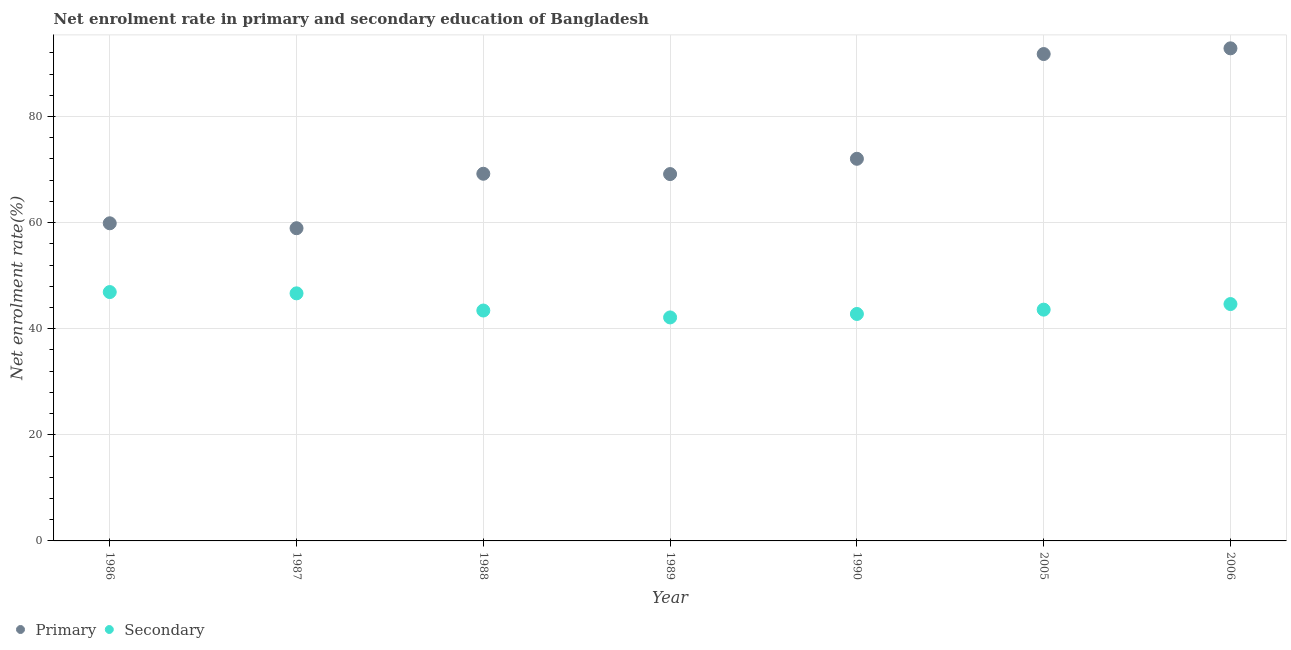Is the number of dotlines equal to the number of legend labels?
Offer a terse response. Yes. What is the enrollment rate in primary education in 1987?
Provide a short and direct response. 58.95. Across all years, what is the maximum enrollment rate in secondary education?
Keep it short and to the point. 46.91. Across all years, what is the minimum enrollment rate in primary education?
Provide a short and direct response. 58.95. In which year was the enrollment rate in secondary education maximum?
Provide a short and direct response. 1986. What is the total enrollment rate in primary education in the graph?
Give a very brief answer. 513.84. What is the difference between the enrollment rate in secondary education in 1987 and that in 2005?
Offer a terse response. 3.07. What is the difference between the enrollment rate in primary education in 1987 and the enrollment rate in secondary education in 1988?
Provide a short and direct response. 15.51. What is the average enrollment rate in primary education per year?
Make the answer very short. 73.41. In the year 1988, what is the difference between the enrollment rate in secondary education and enrollment rate in primary education?
Your answer should be very brief. -25.78. What is the ratio of the enrollment rate in secondary education in 1988 to that in 1990?
Ensure brevity in your answer.  1.02. What is the difference between the highest and the second highest enrollment rate in secondary education?
Offer a terse response. 0.24. What is the difference between the highest and the lowest enrollment rate in secondary education?
Offer a very short reply. 4.78. In how many years, is the enrollment rate in primary education greater than the average enrollment rate in primary education taken over all years?
Offer a very short reply. 2. Does the enrollment rate in primary education monotonically increase over the years?
Provide a short and direct response. No. Is the enrollment rate in secondary education strictly greater than the enrollment rate in primary education over the years?
Make the answer very short. No. How many dotlines are there?
Your response must be concise. 2. How many years are there in the graph?
Your response must be concise. 7. What is the difference between two consecutive major ticks on the Y-axis?
Provide a short and direct response. 20. Are the values on the major ticks of Y-axis written in scientific E-notation?
Ensure brevity in your answer.  No. How are the legend labels stacked?
Your answer should be very brief. Horizontal. What is the title of the graph?
Make the answer very short. Net enrolment rate in primary and secondary education of Bangladesh. What is the label or title of the Y-axis?
Ensure brevity in your answer.  Net enrolment rate(%). What is the Net enrolment rate(%) in Primary in 1986?
Your answer should be very brief. 59.87. What is the Net enrolment rate(%) of Secondary in 1986?
Provide a short and direct response. 46.91. What is the Net enrolment rate(%) of Primary in 1987?
Keep it short and to the point. 58.95. What is the Net enrolment rate(%) in Secondary in 1987?
Give a very brief answer. 46.67. What is the Net enrolment rate(%) of Primary in 1988?
Your response must be concise. 69.21. What is the Net enrolment rate(%) in Secondary in 1988?
Ensure brevity in your answer.  43.43. What is the Net enrolment rate(%) of Primary in 1989?
Provide a short and direct response. 69.15. What is the Net enrolment rate(%) in Secondary in 1989?
Provide a succinct answer. 42.13. What is the Net enrolment rate(%) in Primary in 1990?
Your answer should be very brief. 72.03. What is the Net enrolment rate(%) in Secondary in 1990?
Make the answer very short. 42.78. What is the Net enrolment rate(%) of Primary in 2005?
Offer a very short reply. 91.78. What is the Net enrolment rate(%) in Secondary in 2005?
Offer a very short reply. 43.6. What is the Net enrolment rate(%) in Primary in 2006?
Provide a short and direct response. 92.85. What is the Net enrolment rate(%) in Secondary in 2006?
Keep it short and to the point. 44.65. Across all years, what is the maximum Net enrolment rate(%) of Primary?
Offer a very short reply. 92.85. Across all years, what is the maximum Net enrolment rate(%) in Secondary?
Offer a terse response. 46.91. Across all years, what is the minimum Net enrolment rate(%) in Primary?
Your response must be concise. 58.95. Across all years, what is the minimum Net enrolment rate(%) of Secondary?
Offer a very short reply. 42.13. What is the total Net enrolment rate(%) in Primary in the graph?
Your response must be concise. 513.84. What is the total Net enrolment rate(%) in Secondary in the graph?
Your answer should be very brief. 310.16. What is the difference between the Net enrolment rate(%) of Primary in 1986 and that in 1987?
Give a very brief answer. 0.93. What is the difference between the Net enrolment rate(%) of Secondary in 1986 and that in 1987?
Ensure brevity in your answer.  0.24. What is the difference between the Net enrolment rate(%) in Primary in 1986 and that in 1988?
Offer a terse response. -9.34. What is the difference between the Net enrolment rate(%) in Secondary in 1986 and that in 1988?
Offer a very short reply. 3.48. What is the difference between the Net enrolment rate(%) of Primary in 1986 and that in 1989?
Provide a short and direct response. -9.28. What is the difference between the Net enrolment rate(%) in Secondary in 1986 and that in 1989?
Offer a very short reply. 4.78. What is the difference between the Net enrolment rate(%) of Primary in 1986 and that in 1990?
Offer a very short reply. -12.16. What is the difference between the Net enrolment rate(%) of Secondary in 1986 and that in 1990?
Your answer should be compact. 4.13. What is the difference between the Net enrolment rate(%) in Primary in 1986 and that in 2005?
Make the answer very short. -31.9. What is the difference between the Net enrolment rate(%) in Secondary in 1986 and that in 2005?
Offer a very short reply. 3.31. What is the difference between the Net enrolment rate(%) of Primary in 1986 and that in 2006?
Ensure brevity in your answer.  -32.98. What is the difference between the Net enrolment rate(%) in Secondary in 1986 and that in 2006?
Provide a short and direct response. 2.26. What is the difference between the Net enrolment rate(%) in Primary in 1987 and that in 1988?
Offer a very short reply. -10.27. What is the difference between the Net enrolment rate(%) of Secondary in 1987 and that in 1988?
Give a very brief answer. 3.24. What is the difference between the Net enrolment rate(%) of Primary in 1987 and that in 1989?
Provide a short and direct response. -10.2. What is the difference between the Net enrolment rate(%) in Secondary in 1987 and that in 1989?
Your answer should be very brief. 4.54. What is the difference between the Net enrolment rate(%) of Primary in 1987 and that in 1990?
Your answer should be very brief. -13.09. What is the difference between the Net enrolment rate(%) of Secondary in 1987 and that in 1990?
Make the answer very short. 3.89. What is the difference between the Net enrolment rate(%) in Primary in 1987 and that in 2005?
Your response must be concise. -32.83. What is the difference between the Net enrolment rate(%) in Secondary in 1987 and that in 2005?
Keep it short and to the point. 3.07. What is the difference between the Net enrolment rate(%) of Primary in 1987 and that in 2006?
Offer a very short reply. -33.91. What is the difference between the Net enrolment rate(%) of Secondary in 1987 and that in 2006?
Keep it short and to the point. 2.02. What is the difference between the Net enrolment rate(%) of Primary in 1988 and that in 1989?
Provide a short and direct response. 0.06. What is the difference between the Net enrolment rate(%) of Secondary in 1988 and that in 1989?
Make the answer very short. 1.3. What is the difference between the Net enrolment rate(%) of Primary in 1988 and that in 1990?
Your response must be concise. -2.82. What is the difference between the Net enrolment rate(%) in Secondary in 1988 and that in 1990?
Offer a terse response. 0.65. What is the difference between the Net enrolment rate(%) in Primary in 1988 and that in 2005?
Offer a terse response. -22.57. What is the difference between the Net enrolment rate(%) in Secondary in 1988 and that in 2005?
Keep it short and to the point. -0.17. What is the difference between the Net enrolment rate(%) of Primary in 1988 and that in 2006?
Ensure brevity in your answer.  -23.64. What is the difference between the Net enrolment rate(%) of Secondary in 1988 and that in 2006?
Give a very brief answer. -1.22. What is the difference between the Net enrolment rate(%) in Primary in 1989 and that in 1990?
Give a very brief answer. -2.88. What is the difference between the Net enrolment rate(%) in Secondary in 1989 and that in 1990?
Your response must be concise. -0.65. What is the difference between the Net enrolment rate(%) in Primary in 1989 and that in 2005?
Provide a succinct answer. -22.63. What is the difference between the Net enrolment rate(%) of Secondary in 1989 and that in 2005?
Give a very brief answer. -1.47. What is the difference between the Net enrolment rate(%) of Primary in 1989 and that in 2006?
Offer a very short reply. -23.7. What is the difference between the Net enrolment rate(%) in Secondary in 1989 and that in 2006?
Provide a succinct answer. -2.52. What is the difference between the Net enrolment rate(%) of Primary in 1990 and that in 2005?
Give a very brief answer. -19.75. What is the difference between the Net enrolment rate(%) of Secondary in 1990 and that in 2005?
Offer a very short reply. -0.81. What is the difference between the Net enrolment rate(%) of Primary in 1990 and that in 2006?
Offer a very short reply. -20.82. What is the difference between the Net enrolment rate(%) of Secondary in 1990 and that in 2006?
Keep it short and to the point. -1.87. What is the difference between the Net enrolment rate(%) of Primary in 2005 and that in 2006?
Offer a very short reply. -1.08. What is the difference between the Net enrolment rate(%) in Secondary in 2005 and that in 2006?
Offer a terse response. -1.05. What is the difference between the Net enrolment rate(%) in Primary in 1986 and the Net enrolment rate(%) in Secondary in 1987?
Provide a succinct answer. 13.21. What is the difference between the Net enrolment rate(%) in Primary in 1986 and the Net enrolment rate(%) in Secondary in 1988?
Give a very brief answer. 16.44. What is the difference between the Net enrolment rate(%) in Primary in 1986 and the Net enrolment rate(%) in Secondary in 1989?
Give a very brief answer. 17.74. What is the difference between the Net enrolment rate(%) in Primary in 1986 and the Net enrolment rate(%) in Secondary in 1990?
Offer a terse response. 17.09. What is the difference between the Net enrolment rate(%) of Primary in 1986 and the Net enrolment rate(%) of Secondary in 2005?
Make the answer very short. 16.28. What is the difference between the Net enrolment rate(%) in Primary in 1986 and the Net enrolment rate(%) in Secondary in 2006?
Provide a succinct answer. 15.22. What is the difference between the Net enrolment rate(%) of Primary in 1987 and the Net enrolment rate(%) of Secondary in 1988?
Your answer should be very brief. 15.51. What is the difference between the Net enrolment rate(%) in Primary in 1987 and the Net enrolment rate(%) in Secondary in 1989?
Provide a succinct answer. 16.82. What is the difference between the Net enrolment rate(%) in Primary in 1987 and the Net enrolment rate(%) in Secondary in 1990?
Provide a succinct answer. 16.16. What is the difference between the Net enrolment rate(%) of Primary in 1987 and the Net enrolment rate(%) of Secondary in 2005?
Your answer should be compact. 15.35. What is the difference between the Net enrolment rate(%) in Primary in 1987 and the Net enrolment rate(%) in Secondary in 2006?
Your response must be concise. 14.3. What is the difference between the Net enrolment rate(%) of Primary in 1988 and the Net enrolment rate(%) of Secondary in 1989?
Provide a short and direct response. 27.08. What is the difference between the Net enrolment rate(%) in Primary in 1988 and the Net enrolment rate(%) in Secondary in 1990?
Your response must be concise. 26.43. What is the difference between the Net enrolment rate(%) of Primary in 1988 and the Net enrolment rate(%) of Secondary in 2005?
Offer a very short reply. 25.61. What is the difference between the Net enrolment rate(%) of Primary in 1988 and the Net enrolment rate(%) of Secondary in 2006?
Your answer should be very brief. 24.56. What is the difference between the Net enrolment rate(%) in Primary in 1989 and the Net enrolment rate(%) in Secondary in 1990?
Give a very brief answer. 26.37. What is the difference between the Net enrolment rate(%) of Primary in 1989 and the Net enrolment rate(%) of Secondary in 2005?
Offer a very short reply. 25.55. What is the difference between the Net enrolment rate(%) of Primary in 1989 and the Net enrolment rate(%) of Secondary in 2006?
Provide a short and direct response. 24.5. What is the difference between the Net enrolment rate(%) of Primary in 1990 and the Net enrolment rate(%) of Secondary in 2005?
Ensure brevity in your answer.  28.44. What is the difference between the Net enrolment rate(%) of Primary in 1990 and the Net enrolment rate(%) of Secondary in 2006?
Your answer should be very brief. 27.38. What is the difference between the Net enrolment rate(%) of Primary in 2005 and the Net enrolment rate(%) of Secondary in 2006?
Your answer should be compact. 47.13. What is the average Net enrolment rate(%) of Primary per year?
Provide a short and direct response. 73.41. What is the average Net enrolment rate(%) of Secondary per year?
Offer a terse response. 44.31. In the year 1986, what is the difference between the Net enrolment rate(%) of Primary and Net enrolment rate(%) of Secondary?
Provide a succinct answer. 12.96. In the year 1987, what is the difference between the Net enrolment rate(%) of Primary and Net enrolment rate(%) of Secondary?
Make the answer very short. 12.28. In the year 1988, what is the difference between the Net enrolment rate(%) in Primary and Net enrolment rate(%) in Secondary?
Provide a succinct answer. 25.78. In the year 1989, what is the difference between the Net enrolment rate(%) of Primary and Net enrolment rate(%) of Secondary?
Provide a short and direct response. 27.02. In the year 1990, what is the difference between the Net enrolment rate(%) of Primary and Net enrolment rate(%) of Secondary?
Your response must be concise. 29.25. In the year 2005, what is the difference between the Net enrolment rate(%) of Primary and Net enrolment rate(%) of Secondary?
Give a very brief answer. 48.18. In the year 2006, what is the difference between the Net enrolment rate(%) of Primary and Net enrolment rate(%) of Secondary?
Your response must be concise. 48.2. What is the ratio of the Net enrolment rate(%) of Primary in 1986 to that in 1987?
Your response must be concise. 1.02. What is the ratio of the Net enrolment rate(%) of Primary in 1986 to that in 1988?
Offer a very short reply. 0.87. What is the ratio of the Net enrolment rate(%) in Secondary in 1986 to that in 1988?
Give a very brief answer. 1.08. What is the ratio of the Net enrolment rate(%) in Primary in 1986 to that in 1989?
Make the answer very short. 0.87. What is the ratio of the Net enrolment rate(%) of Secondary in 1986 to that in 1989?
Offer a terse response. 1.11. What is the ratio of the Net enrolment rate(%) of Primary in 1986 to that in 1990?
Provide a short and direct response. 0.83. What is the ratio of the Net enrolment rate(%) of Secondary in 1986 to that in 1990?
Your answer should be compact. 1.1. What is the ratio of the Net enrolment rate(%) of Primary in 1986 to that in 2005?
Your answer should be very brief. 0.65. What is the ratio of the Net enrolment rate(%) of Secondary in 1986 to that in 2005?
Give a very brief answer. 1.08. What is the ratio of the Net enrolment rate(%) in Primary in 1986 to that in 2006?
Your answer should be compact. 0.64. What is the ratio of the Net enrolment rate(%) in Secondary in 1986 to that in 2006?
Keep it short and to the point. 1.05. What is the ratio of the Net enrolment rate(%) of Primary in 1987 to that in 1988?
Provide a succinct answer. 0.85. What is the ratio of the Net enrolment rate(%) in Secondary in 1987 to that in 1988?
Provide a succinct answer. 1.07. What is the ratio of the Net enrolment rate(%) of Primary in 1987 to that in 1989?
Offer a terse response. 0.85. What is the ratio of the Net enrolment rate(%) of Secondary in 1987 to that in 1989?
Ensure brevity in your answer.  1.11. What is the ratio of the Net enrolment rate(%) in Primary in 1987 to that in 1990?
Provide a succinct answer. 0.82. What is the ratio of the Net enrolment rate(%) in Primary in 1987 to that in 2005?
Provide a succinct answer. 0.64. What is the ratio of the Net enrolment rate(%) of Secondary in 1987 to that in 2005?
Give a very brief answer. 1.07. What is the ratio of the Net enrolment rate(%) in Primary in 1987 to that in 2006?
Give a very brief answer. 0.63. What is the ratio of the Net enrolment rate(%) in Secondary in 1987 to that in 2006?
Ensure brevity in your answer.  1.05. What is the ratio of the Net enrolment rate(%) of Primary in 1988 to that in 1989?
Make the answer very short. 1. What is the ratio of the Net enrolment rate(%) of Secondary in 1988 to that in 1989?
Offer a very short reply. 1.03. What is the ratio of the Net enrolment rate(%) in Primary in 1988 to that in 1990?
Keep it short and to the point. 0.96. What is the ratio of the Net enrolment rate(%) in Secondary in 1988 to that in 1990?
Your answer should be compact. 1.02. What is the ratio of the Net enrolment rate(%) of Primary in 1988 to that in 2005?
Make the answer very short. 0.75. What is the ratio of the Net enrolment rate(%) of Primary in 1988 to that in 2006?
Your response must be concise. 0.75. What is the ratio of the Net enrolment rate(%) in Secondary in 1988 to that in 2006?
Make the answer very short. 0.97. What is the ratio of the Net enrolment rate(%) in Primary in 1989 to that in 2005?
Provide a succinct answer. 0.75. What is the ratio of the Net enrolment rate(%) in Secondary in 1989 to that in 2005?
Keep it short and to the point. 0.97. What is the ratio of the Net enrolment rate(%) in Primary in 1989 to that in 2006?
Your answer should be very brief. 0.74. What is the ratio of the Net enrolment rate(%) in Secondary in 1989 to that in 2006?
Ensure brevity in your answer.  0.94. What is the ratio of the Net enrolment rate(%) in Primary in 1990 to that in 2005?
Give a very brief answer. 0.78. What is the ratio of the Net enrolment rate(%) of Secondary in 1990 to that in 2005?
Make the answer very short. 0.98. What is the ratio of the Net enrolment rate(%) of Primary in 1990 to that in 2006?
Keep it short and to the point. 0.78. What is the ratio of the Net enrolment rate(%) in Secondary in 1990 to that in 2006?
Give a very brief answer. 0.96. What is the ratio of the Net enrolment rate(%) in Primary in 2005 to that in 2006?
Your answer should be compact. 0.99. What is the ratio of the Net enrolment rate(%) of Secondary in 2005 to that in 2006?
Give a very brief answer. 0.98. What is the difference between the highest and the second highest Net enrolment rate(%) of Primary?
Keep it short and to the point. 1.08. What is the difference between the highest and the second highest Net enrolment rate(%) of Secondary?
Make the answer very short. 0.24. What is the difference between the highest and the lowest Net enrolment rate(%) of Primary?
Your response must be concise. 33.91. What is the difference between the highest and the lowest Net enrolment rate(%) in Secondary?
Your response must be concise. 4.78. 